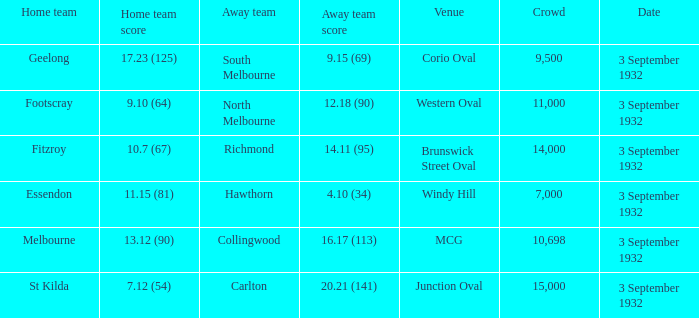21 (141)? 3 September 1932. 